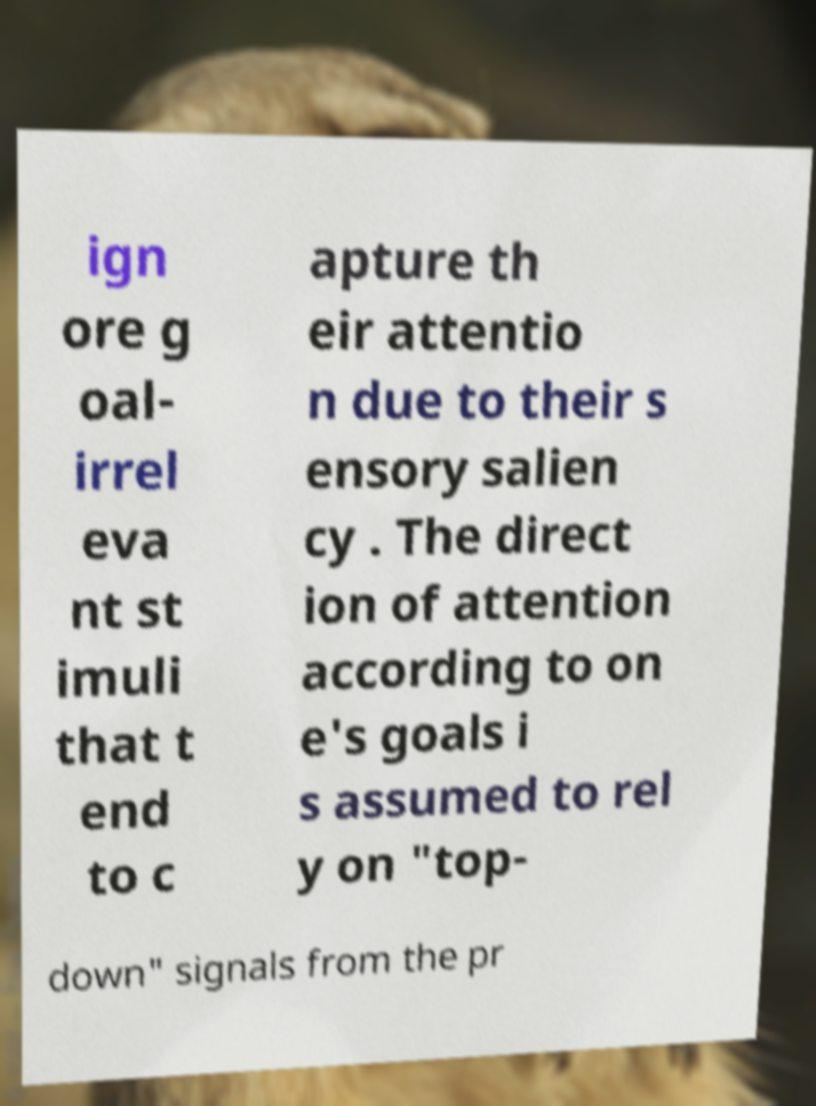There's text embedded in this image that I need extracted. Can you transcribe it verbatim? ign ore g oal- irrel eva nt st imuli that t end to c apture th eir attentio n due to their s ensory salien cy . The direct ion of attention according to on e's goals i s assumed to rel y on "top- down" signals from the pr 